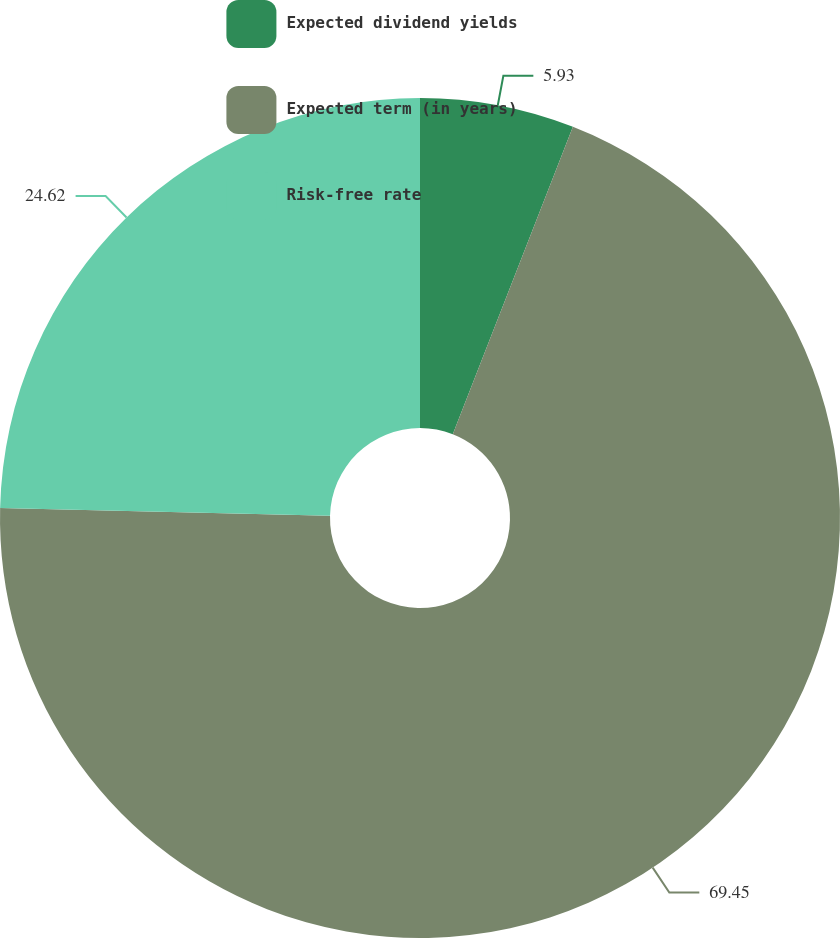<chart> <loc_0><loc_0><loc_500><loc_500><pie_chart><fcel>Expected dividend yields<fcel>Expected term (in years)<fcel>Risk-free rate<nl><fcel>5.93%<fcel>69.44%<fcel>24.62%<nl></chart> 